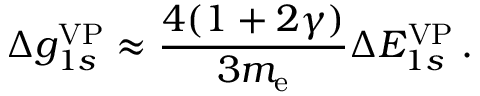Convert formula to latex. <formula><loc_0><loc_0><loc_500><loc_500>\Delta { g } _ { 1 s } ^ { V P } \approx \frac { 4 ( 1 + 2 \gamma ) } { 3 m _ { e } } \Delta { E } _ { 1 s } ^ { V P } \, .</formula> 